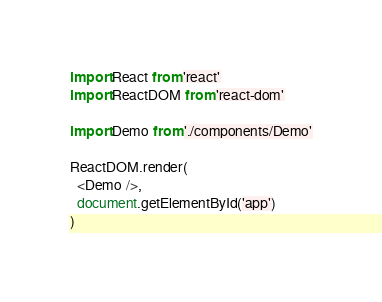<code> <loc_0><loc_0><loc_500><loc_500><_JavaScript_>import React from 'react'
import ReactDOM from 'react-dom'

import Demo from './components/Demo'

ReactDOM.render(
  <Demo />,
  document.getElementById('app')
)
</code> 